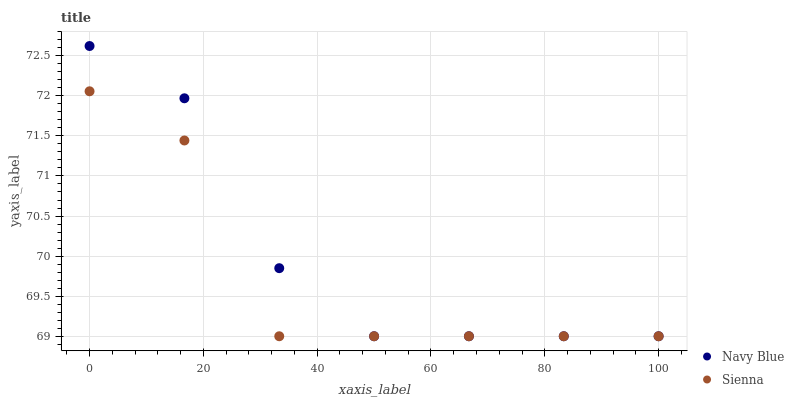Does Sienna have the minimum area under the curve?
Answer yes or no. Yes. Does Navy Blue have the maximum area under the curve?
Answer yes or no. Yes. Does Navy Blue have the minimum area under the curve?
Answer yes or no. No. Is Navy Blue the smoothest?
Answer yes or no. Yes. Is Sienna the roughest?
Answer yes or no. Yes. Is Navy Blue the roughest?
Answer yes or no. No. Does Sienna have the lowest value?
Answer yes or no. Yes. Does Navy Blue have the highest value?
Answer yes or no. Yes. Does Sienna intersect Navy Blue?
Answer yes or no. Yes. Is Sienna less than Navy Blue?
Answer yes or no. No. Is Sienna greater than Navy Blue?
Answer yes or no. No. 